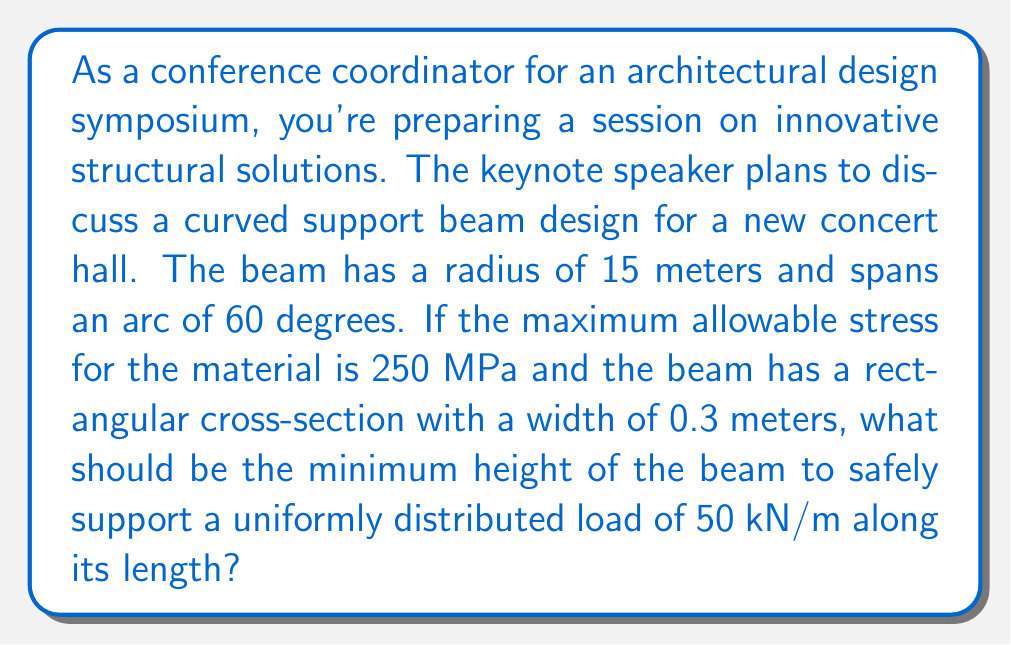Can you answer this question? To solve this problem, we'll follow these steps:

1. Calculate the length of the curved beam:
   $$L = R \theta = 15 \text{ m} \cdot \frac{\pi}{3} \text{ rad} = 15.71 \text{ m}$$

2. Determine the total load on the beam:
   $$W = 50 \text{ kN/m} \cdot 15.71 \text{ m} = 785.5 \text{ kN}$$

3. Calculate the bending moment at the center of the beam:
   $$M = \frac{WR}{2} = \frac{785.5 \text{ kN} \cdot 15 \text{ m}}{2} = 5891.25 \text{ kN}\cdot\text{m}$$

4. Use the flexure formula to relate stress, moment, and section properties:
   $$\sigma = \frac{My}{I}$$
   where $\sigma$ is the maximum stress, $M$ is the bending moment, $y$ is the distance from the neutral axis to the extreme fiber (half the height), and $I$ is the moment of inertia.

5. For a rectangular cross-section, the moment of inertia is:
   $$I = \frac{bh^3}{12}$$
   where $b$ is the width and $h$ is the height.

6. Substitute these into the flexure formula:
   $$250 \text{ MPa} = \frac{5891.25 \cdot 10^6 \text{ N}\cdot\text{m} \cdot (h/2)}{\frac{0.3 \text{ m} \cdot h^3}{12}}$$

7. Simplify and solve for $h$:
   $$250 \cdot 10^6 = \frac{5891.25 \cdot 10^6 \cdot 6}{0.3 \cdot h^2}$$
   $$h^2 = \frac{5891.25 \cdot 10^6 \cdot 6}{250 \cdot 10^6 \cdot 0.3} = 4.71$$
   $$h = \sqrt{4.71} = 2.17 \text{ m}$$

Therefore, the minimum height of the beam should be 2.17 meters to safely support the given load.
Answer: The minimum height of the curved support beam should be 2.17 meters. 